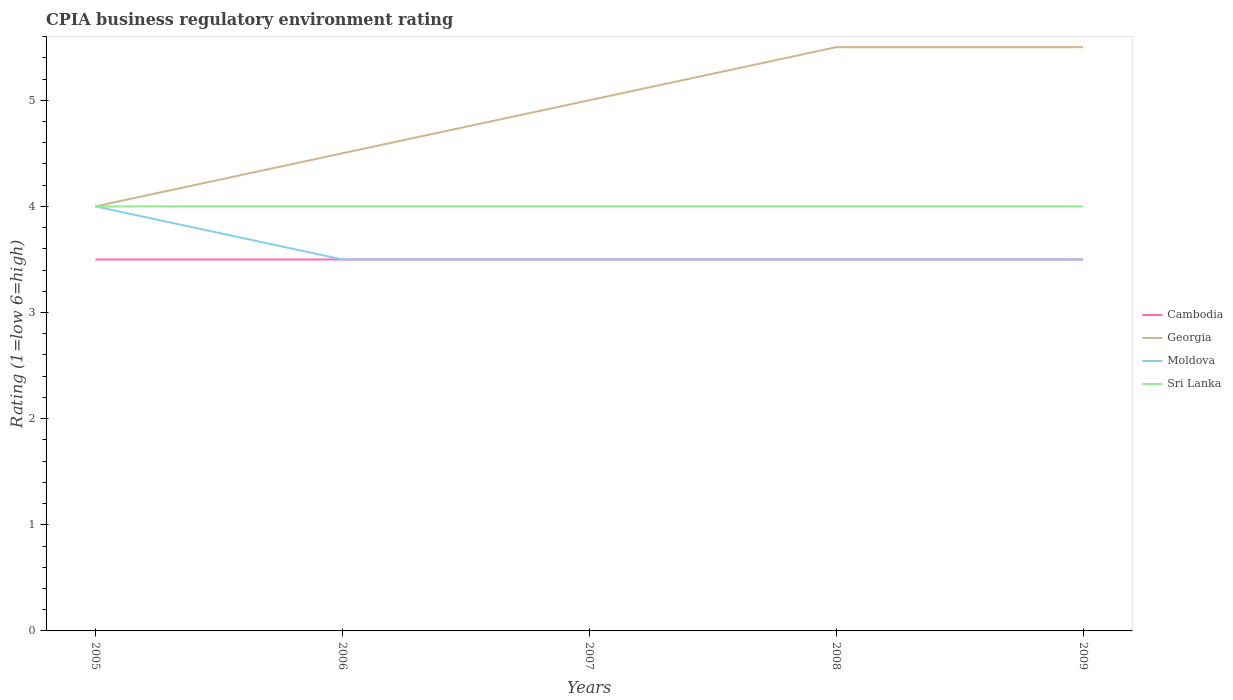How many different coloured lines are there?
Make the answer very short. 4. Does the line corresponding to Sri Lanka intersect with the line corresponding to Georgia?
Keep it short and to the point. Yes. Across all years, what is the maximum CPIA rating in Cambodia?
Offer a terse response. 3.5. What is the total CPIA rating in Moldova in the graph?
Provide a short and direct response. 0.5. What is the difference between the highest and the second highest CPIA rating in Moldova?
Your response must be concise. 0.5. How many lines are there?
Provide a succinct answer. 4. How many years are there in the graph?
Give a very brief answer. 5. How many legend labels are there?
Ensure brevity in your answer.  4. What is the title of the graph?
Offer a very short reply. CPIA business regulatory environment rating. Does "Argentina" appear as one of the legend labels in the graph?
Your answer should be very brief. No. What is the label or title of the X-axis?
Your answer should be very brief. Years. What is the Rating (1=low 6=high) of Georgia in 2005?
Make the answer very short. 4. What is the Rating (1=low 6=high) in Sri Lanka in 2005?
Offer a terse response. 4. What is the Rating (1=low 6=high) in Moldova in 2006?
Offer a very short reply. 3.5. What is the Rating (1=low 6=high) in Cambodia in 2007?
Make the answer very short. 3.5. What is the Rating (1=low 6=high) in Sri Lanka in 2007?
Keep it short and to the point. 4. What is the Rating (1=low 6=high) in Cambodia in 2009?
Make the answer very short. 3.5. What is the Rating (1=low 6=high) of Georgia in 2009?
Keep it short and to the point. 5.5. What is the Rating (1=low 6=high) of Moldova in 2009?
Your response must be concise. 3.5. Across all years, what is the maximum Rating (1=low 6=high) in Cambodia?
Offer a very short reply. 3.5. Across all years, what is the maximum Rating (1=low 6=high) in Georgia?
Ensure brevity in your answer.  5.5. Across all years, what is the maximum Rating (1=low 6=high) in Moldova?
Give a very brief answer. 4. Across all years, what is the maximum Rating (1=low 6=high) in Sri Lanka?
Provide a short and direct response. 4. Across all years, what is the minimum Rating (1=low 6=high) in Cambodia?
Your answer should be compact. 3.5. Across all years, what is the minimum Rating (1=low 6=high) of Georgia?
Provide a succinct answer. 4. Across all years, what is the minimum Rating (1=low 6=high) of Moldova?
Your response must be concise. 3.5. What is the total Rating (1=low 6=high) of Cambodia in the graph?
Keep it short and to the point. 17.5. What is the total Rating (1=low 6=high) in Georgia in the graph?
Provide a succinct answer. 24.5. What is the difference between the Rating (1=low 6=high) in Cambodia in 2005 and that in 2006?
Offer a very short reply. 0. What is the difference between the Rating (1=low 6=high) of Moldova in 2005 and that in 2006?
Ensure brevity in your answer.  0.5. What is the difference between the Rating (1=low 6=high) in Cambodia in 2005 and that in 2007?
Make the answer very short. 0. What is the difference between the Rating (1=low 6=high) of Georgia in 2005 and that in 2007?
Make the answer very short. -1. What is the difference between the Rating (1=low 6=high) of Moldova in 2005 and that in 2007?
Provide a short and direct response. 0.5. What is the difference between the Rating (1=low 6=high) in Sri Lanka in 2005 and that in 2007?
Offer a very short reply. 0. What is the difference between the Rating (1=low 6=high) of Cambodia in 2005 and that in 2008?
Offer a very short reply. 0. What is the difference between the Rating (1=low 6=high) in Georgia in 2005 and that in 2008?
Ensure brevity in your answer.  -1.5. What is the difference between the Rating (1=low 6=high) in Moldova in 2005 and that in 2008?
Keep it short and to the point. 0.5. What is the difference between the Rating (1=low 6=high) in Georgia in 2005 and that in 2009?
Make the answer very short. -1.5. What is the difference between the Rating (1=low 6=high) of Moldova in 2005 and that in 2009?
Make the answer very short. 0.5. What is the difference between the Rating (1=low 6=high) in Sri Lanka in 2005 and that in 2009?
Provide a short and direct response. 0. What is the difference between the Rating (1=low 6=high) in Cambodia in 2006 and that in 2007?
Give a very brief answer. 0. What is the difference between the Rating (1=low 6=high) of Georgia in 2006 and that in 2007?
Your response must be concise. -0.5. What is the difference between the Rating (1=low 6=high) in Moldova in 2006 and that in 2007?
Give a very brief answer. 0. What is the difference between the Rating (1=low 6=high) in Cambodia in 2006 and that in 2008?
Your answer should be very brief. 0. What is the difference between the Rating (1=low 6=high) in Georgia in 2006 and that in 2008?
Offer a terse response. -1. What is the difference between the Rating (1=low 6=high) in Moldova in 2006 and that in 2008?
Ensure brevity in your answer.  0. What is the difference between the Rating (1=low 6=high) of Sri Lanka in 2006 and that in 2008?
Your answer should be very brief. 0. What is the difference between the Rating (1=low 6=high) in Georgia in 2006 and that in 2009?
Your answer should be very brief. -1. What is the difference between the Rating (1=low 6=high) in Sri Lanka in 2006 and that in 2009?
Your answer should be compact. 0. What is the difference between the Rating (1=low 6=high) of Sri Lanka in 2007 and that in 2008?
Your answer should be compact. 0. What is the difference between the Rating (1=low 6=high) of Moldova in 2007 and that in 2009?
Provide a succinct answer. 0. What is the difference between the Rating (1=low 6=high) of Sri Lanka in 2007 and that in 2009?
Provide a succinct answer. 0. What is the difference between the Rating (1=low 6=high) in Georgia in 2008 and that in 2009?
Your answer should be very brief. 0. What is the difference between the Rating (1=low 6=high) of Moldova in 2008 and that in 2009?
Your answer should be compact. 0. What is the difference between the Rating (1=low 6=high) of Sri Lanka in 2008 and that in 2009?
Keep it short and to the point. 0. What is the difference between the Rating (1=low 6=high) in Cambodia in 2005 and the Rating (1=low 6=high) in Moldova in 2006?
Ensure brevity in your answer.  0. What is the difference between the Rating (1=low 6=high) in Cambodia in 2005 and the Rating (1=low 6=high) in Sri Lanka in 2006?
Your answer should be very brief. -0.5. What is the difference between the Rating (1=low 6=high) in Georgia in 2005 and the Rating (1=low 6=high) in Moldova in 2006?
Your response must be concise. 0.5. What is the difference between the Rating (1=low 6=high) in Georgia in 2005 and the Rating (1=low 6=high) in Sri Lanka in 2006?
Your answer should be compact. 0. What is the difference between the Rating (1=low 6=high) in Moldova in 2005 and the Rating (1=low 6=high) in Sri Lanka in 2006?
Give a very brief answer. 0. What is the difference between the Rating (1=low 6=high) in Cambodia in 2005 and the Rating (1=low 6=high) in Georgia in 2007?
Make the answer very short. -1.5. What is the difference between the Rating (1=low 6=high) in Cambodia in 2005 and the Rating (1=low 6=high) in Moldova in 2007?
Ensure brevity in your answer.  0. What is the difference between the Rating (1=low 6=high) of Georgia in 2005 and the Rating (1=low 6=high) of Sri Lanka in 2007?
Your response must be concise. 0. What is the difference between the Rating (1=low 6=high) of Moldova in 2005 and the Rating (1=low 6=high) of Sri Lanka in 2007?
Provide a short and direct response. 0. What is the difference between the Rating (1=low 6=high) in Cambodia in 2005 and the Rating (1=low 6=high) in Moldova in 2008?
Make the answer very short. 0. What is the difference between the Rating (1=low 6=high) in Georgia in 2005 and the Rating (1=low 6=high) in Moldova in 2008?
Your answer should be compact. 0.5. What is the difference between the Rating (1=low 6=high) in Moldova in 2005 and the Rating (1=low 6=high) in Sri Lanka in 2008?
Keep it short and to the point. 0. What is the difference between the Rating (1=low 6=high) of Georgia in 2005 and the Rating (1=low 6=high) of Moldova in 2009?
Offer a very short reply. 0.5. What is the difference between the Rating (1=low 6=high) in Cambodia in 2006 and the Rating (1=low 6=high) in Georgia in 2007?
Provide a short and direct response. -1.5. What is the difference between the Rating (1=low 6=high) in Georgia in 2006 and the Rating (1=low 6=high) in Moldova in 2007?
Keep it short and to the point. 1. What is the difference between the Rating (1=low 6=high) in Cambodia in 2006 and the Rating (1=low 6=high) in Moldova in 2008?
Keep it short and to the point. 0. What is the difference between the Rating (1=low 6=high) in Cambodia in 2006 and the Rating (1=low 6=high) in Sri Lanka in 2008?
Provide a succinct answer. -0.5. What is the difference between the Rating (1=low 6=high) of Georgia in 2006 and the Rating (1=low 6=high) of Sri Lanka in 2008?
Keep it short and to the point. 0.5. What is the difference between the Rating (1=low 6=high) in Cambodia in 2006 and the Rating (1=low 6=high) in Moldova in 2009?
Keep it short and to the point. 0. What is the difference between the Rating (1=low 6=high) in Cambodia in 2007 and the Rating (1=low 6=high) in Georgia in 2008?
Your answer should be very brief. -2. What is the difference between the Rating (1=low 6=high) in Cambodia in 2007 and the Rating (1=low 6=high) in Moldova in 2008?
Your answer should be very brief. 0. What is the difference between the Rating (1=low 6=high) in Georgia in 2007 and the Rating (1=low 6=high) in Moldova in 2008?
Give a very brief answer. 1.5. What is the difference between the Rating (1=low 6=high) of Moldova in 2007 and the Rating (1=low 6=high) of Sri Lanka in 2008?
Your response must be concise. -0.5. What is the difference between the Rating (1=low 6=high) of Cambodia in 2007 and the Rating (1=low 6=high) of Sri Lanka in 2009?
Ensure brevity in your answer.  -0.5. What is the difference between the Rating (1=low 6=high) of Georgia in 2007 and the Rating (1=low 6=high) of Moldova in 2009?
Keep it short and to the point. 1.5. What is the difference between the Rating (1=low 6=high) in Georgia in 2007 and the Rating (1=low 6=high) in Sri Lanka in 2009?
Ensure brevity in your answer.  1. What is the difference between the Rating (1=low 6=high) in Moldova in 2007 and the Rating (1=low 6=high) in Sri Lanka in 2009?
Provide a succinct answer. -0.5. What is the difference between the Rating (1=low 6=high) of Cambodia in 2008 and the Rating (1=low 6=high) of Moldova in 2009?
Offer a very short reply. 0. What is the difference between the Rating (1=low 6=high) in Georgia in 2008 and the Rating (1=low 6=high) in Sri Lanka in 2009?
Your answer should be very brief. 1.5. What is the average Rating (1=low 6=high) in Cambodia per year?
Provide a short and direct response. 3.5. What is the average Rating (1=low 6=high) of Georgia per year?
Provide a succinct answer. 4.9. What is the average Rating (1=low 6=high) in Moldova per year?
Your response must be concise. 3.6. In the year 2005, what is the difference between the Rating (1=low 6=high) of Cambodia and Rating (1=low 6=high) of Georgia?
Offer a terse response. -0.5. In the year 2005, what is the difference between the Rating (1=low 6=high) in Cambodia and Rating (1=low 6=high) in Moldova?
Make the answer very short. -0.5. In the year 2005, what is the difference between the Rating (1=low 6=high) in Cambodia and Rating (1=low 6=high) in Sri Lanka?
Your answer should be compact. -0.5. In the year 2005, what is the difference between the Rating (1=low 6=high) of Georgia and Rating (1=low 6=high) of Moldova?
Offer a very short reply. 0. In the year 2005, what is the difference between the Rating (1=low 6=high) in Georgia and Rating (1=low 6=high) in Sri Lanka?
Your answer should be compact. 0. In the year 2006, what is the difference between the Rating (1=low 6=high) of Cambodia and Rating (1=low 6=high) of Georgia?
Make the answer very short. -1. In the year 2006, what is the difference between the Rating (1=low 6=high) of Cambodia and Rating (1=low 6=high) of Moldova?
Keep it short and to the point. 0. In the year 2006, what is the difference between the Rating (1=low 6=high) of Cambodia and Rating (1=low 6=high) of Sri Lanka?
Make the answer very short. -0.5. In the year 2006, what is the difference between the Rating (1=low 6=high) in Georgia and Rating (1=low 6=high) in Moldova?
Your response must be concise. 1. In the year 2006, what is the difference between the Rating (1=low 6=high) of Moldova and Rating (1=low 6=high) of Sri Lanka?
Provide a succinct answer. -0.5. In the year 2007, what is the difference between the Rating (1=low 6=high) in Cambodia and Rating (1=low 6=high) in Georgia?
Give a very brief answer. -1.5. In the year 2007, what is the difference between the Rating (1=low 6=high) of Cambodia and Rating (1=low 6=high) of Moldova?
Give a very brief answer. 0. In the year 2007, what is the difference between the Rating (1=low 6=high) of Cambodia and Rating (1=low 6=high) of Sri Lanka?
Offer a terse response. -0.5. In the year 2008, what is the difference between the Rating (1=low 6=high) of Cambodia and Rating (1=low 6=high) of Georgia?
Provide a short and direct response. -2. In the year 2008, what is the difference between the Rating (1=low 6=high) in Georgia and Rating (1=low 6=high) in Sri Lanka?
Give a very brief answer. 1.5. In the year 2009, what is the difference between the Rating (1=low 6=high) in Cambodia and Rating (1=low 6=high) in Sri Lanka?
Provide a short and direct response. -0.5. In the year 2009, what is the difference between the Rating (1=low 6=high) in Georgia and Rating (1=low 6=high) in Moldova?
Give a very brief answer. 2. In the year 2009, what is the difference between the Rating (1=low 6=high) in Georgia and Rating (1=low 6=high) in Sri Lanka?
Your answer should be compact. 1.5. In the year 2009, what is the difference between the Rating (1=low 6=high) of Moldova and Rating (1=low 6=high) of Sri Lanka?
Provide a succinct answer. -0.5. What is the ratio of the Rating (1=low 6=high) of Georgia in 2005 to that in 2006?
Give a very brief answer. 0.89. What is the ratio of the Rating (1=low 6=high) of Moldova in 2005 to that in 2006?
Make the answer very short. 1.14. What is the ratio of the Rating (1=low 6=high) of Sri Lanka in 2005 to that in 2006?
Offer a terse response. 1. What is the ratio of the Rating (1=low 6=high) in Georgia in 2005 to that in 2007?
Your answer should be compact. 0.8. What is the ratio of the Rating (1=low 6=high) in Sri Lanka in 2005 to that in 2007?
Provide a succinct answer. 1. What is the ratio of the Rating (1=low 6=high) in Cambodia in 2005 to that in 2008?
Make the answer very short. 1. What is the ratio of the Rating (1=low 6=high) in Georgia in 2005 to that in 2008?
Offer a terse response. 0.73. What is the ratio of the Rating (1=low 6=high) of Moldova in 2005 to that in 2008?
Your answer should be very brief. 1.14. What is the ratio of the Rating (1=low 6=high) in Georgia in 2005 to that in 2009?
Keep it short and to the point. 0.73. What is the ratio of the Rating (1=low 6=high) of Moldova in 2005 to that in 2009?
Your response must be concise. 1.14. What is the ratio of the Rating (1=low 6=high) of Moldova in 2006 to that in 2007?
Keep it short and to the point. 1. What is the ratio of the Rating (1=low 6=high) in Sri Lanka in 2006 to that in 2007?
Provide a short and direct response. 1. What is the ratio of the Rating (1=low 6=high) in Cambodia in 2006 to that in 2008?
Offer a terse response. 1. What is the ratio of the Rating (1=low 6=high) in Georgia in 2006 to that in 2008?
Keep it short and to the point. 0.82. What is the ratio of the Rating (1=low 6=high) in Moldova in 2006 to that in 2008?
Give a very brief answer. 1. What is the ratio of the Rating (1=low 6=high) in Sri Lanka in 2006 to that in 2008?
Your answer should be compact. 1. What is the ratio of the Rating (1=low 6=high) in Cambodia in 2006 to that in 2009?
Your response must be concise. 1. What is the ratio of the Rating (1=low 6=high) of Georgia in 2006 to that in 2009?
Make the answer very short. 0.82. What is the ratio of the Rating (1=low 6=high) of Moldova in 2006 to that in 2009?
Give a very brief answer. 1. What is the ratio of the Rating (1=low 6=high) of Georgia in 2007 to that in 2008?
Ensure brevity in your answer.  0.91. What is the ratio of the Rating (1=low 6=high) in Sri Lanka in 2007 to that in 2008?
Make the answer very short. 1. What is the ratio of the Rating (1=low 6=high) of Cambodia in 2007 to that in 2009?
Provide a succinct answer. 1. What is the ratio of the Rating (1=low 6=high) in Georgia in 2007 to that in 2009?
Your response must be concise. 0.91. What is the ratio of the Rating (1=low 6=high) in Georgia in 2008 to that in 2009?
Provide a succinct answer. 1. What is the ratio of the Rating (1=low 6=high) of Moldova in 2008 to that in 2009?
Your answer should be compact. 1. What is the ratio of the Rating (1=low 6=high) in Sri Lanka in 2008 to that in 2009?
Your answer should be very brief. 1. What is the difference between the highest and the second highest Rating (1=low 6=high) in Georgia?
Keep it short and to the point. 0. What is the difference between the highest and the second highest Rating (1=low 6=high) in Moldova?
Keep it short and to the point. 0.5. What is the difference between the highest and the lowest Rating (1=low 6=high) in Moldova?
Make the answer very short. 0.5. 